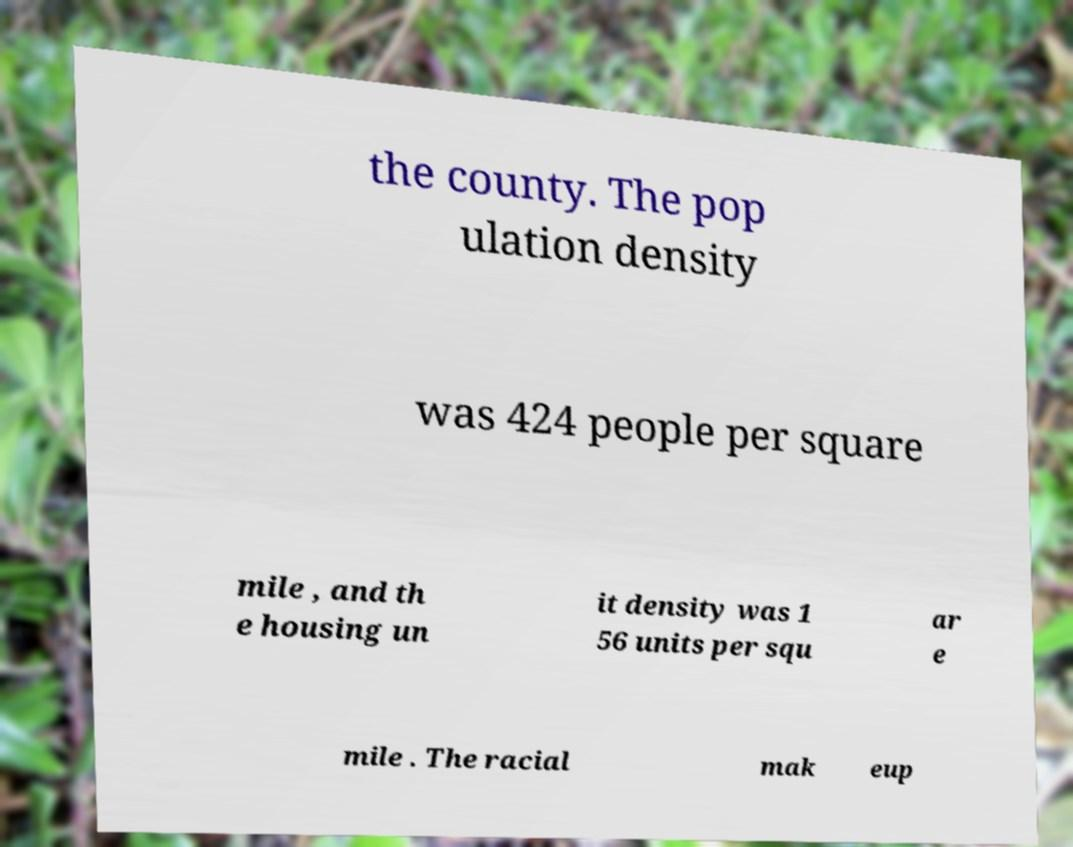Please identify and transcribe the text found in this image. the county. The pop ulation density was 424 people per square mile , and th e housing un it density was 1 56 units per squ ar e mile . The racial mak eup 